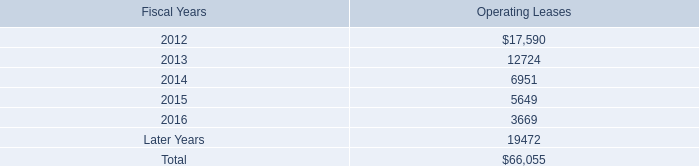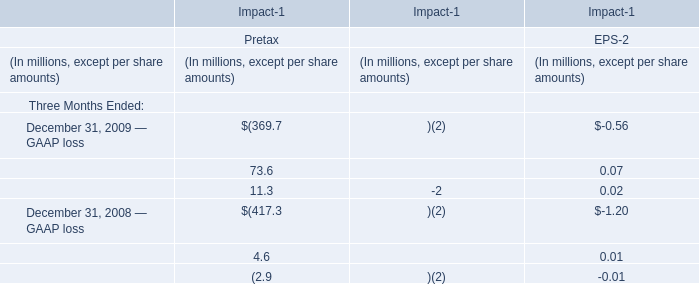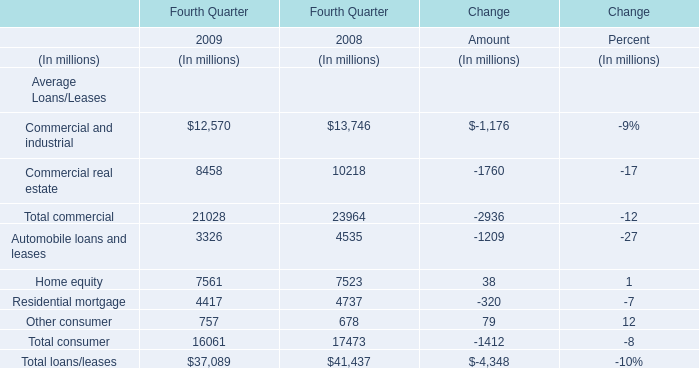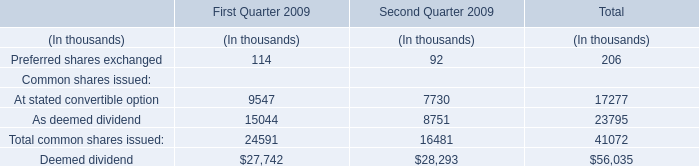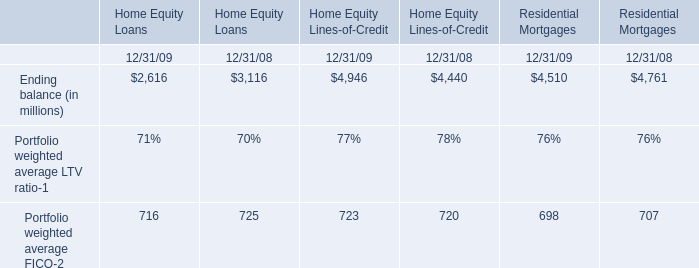what is the growth rate in the total expense related to the defined contribution plan for non-u.s.employees in 2011? 
Computations: ((21.4 - 11.7) / 11.7)
Answer: 0.82906. 